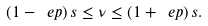<formula> <loc_0><loc_0><loc_500><loc_500>( 1 - \ e p ) \, s \leq \nu \leq ( 1 + \ e p ) \, s .</formula> 